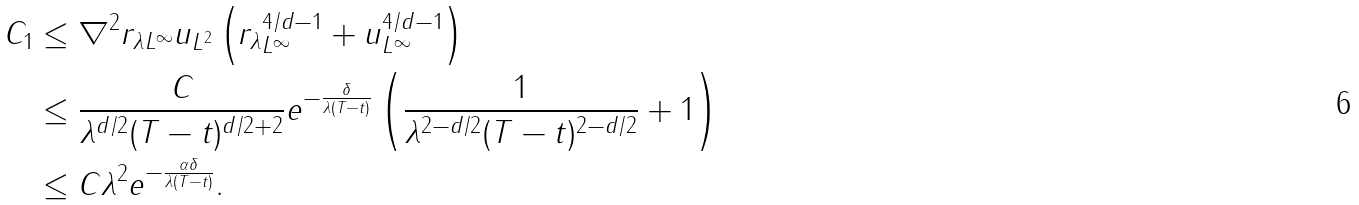Convert formula to latex. <formula><loc_0><loc_0><loc_500><loc_500>C _ { 1 } & \leq \| \nabla ^ { 2 } r _ { \lambda } \| _ { L ^ { \infty } } \| u \| _ { L ^ { 2 } } \left ( \| r _ { \lambda } \| _ { L ^ { \infty } } ^ { 4 / d - 1 } + \| u \| _ { L ^ { \infty } } ^ { 4 / d - 1 } \right ) \\ & \leq \frac { C } { \lambda ^ { d / 2 } ( T - t ) ^ { d / 2 + 2 } } e ^ { - \frac { \delta } { \lambda ( T - t ) } } \left ( \frac { 1 } { \lambda ^ { 2 - d / 2 } ( T - t ) ^ { 2 - d / 2 } } + 1 \right ) \\ & \leq C \lambda ^ { 2 } e ^ { - \frac { \alpha \delta } { \lambda ( T - t ) } } .</formula> 